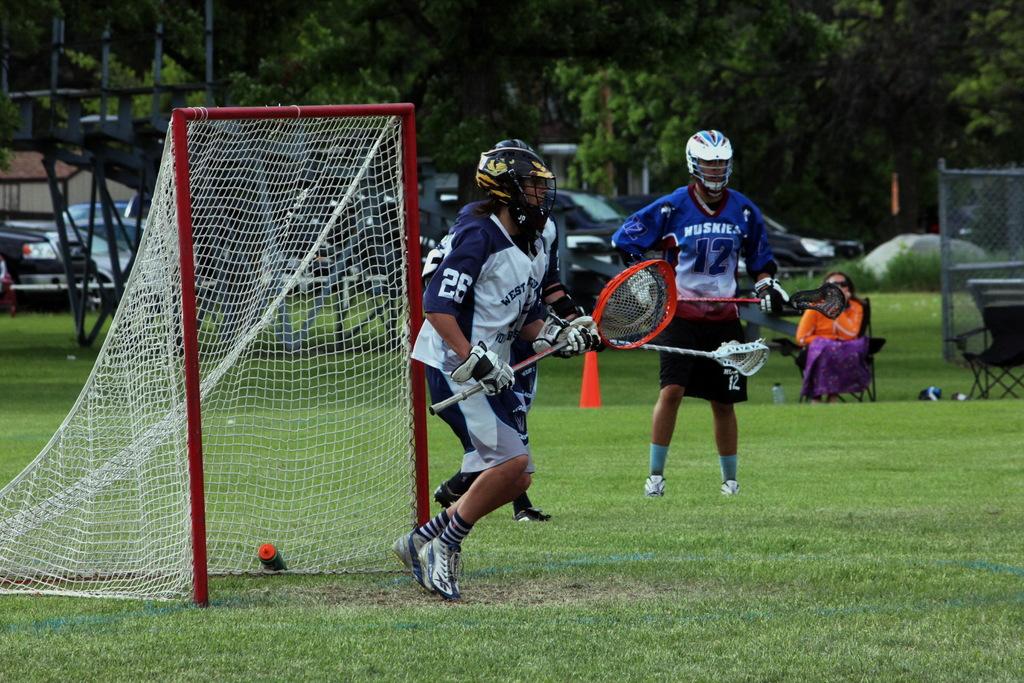What is the number of the goalie?
Give a very brief answer. 26. What is the word above the number 12 on the front of the player's shirt?
Make the answer very short. Huskies. 